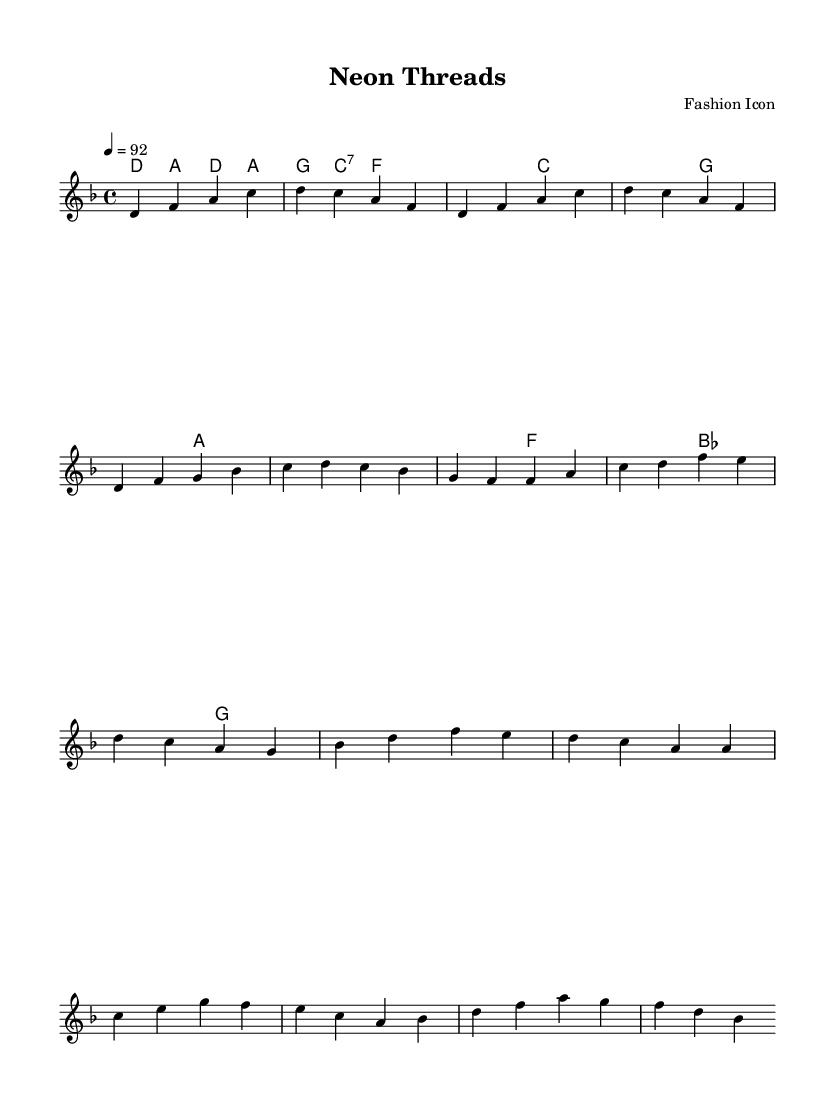What is the key signature of this music? The key signature is D minor, which contains one flat (B flat). This can be determined by looking for the sharps or flats indicated at the beginning of the piece, where the key signature is typically located.
Answer: D minor What is the time signature of this music? The time signature is 4/4, as shown at the beginning of the piece. This means there are four beats in each measure, and a quarter note receives one beat, which is confirmed by the notation after the key signature.
Answer: 4/4 What is the tempo marking of this music? The tempo marking is a quarter note equals 92 beats per minute. This is specified in the tempo directive at the beginning of the score, which indicates how fast the music should be played.
Answer: 92 How many measures are in the chorus section? The chorus section contains four measures, which can be counted by locating the measures in the chart following the introduction and verse sections. Each vertical bar line denotes a measure, and there are four such divisions in the indicated chorus area.
Answer: 4 Which chord is played during the introduction? The first chord in the introduction is D minor. This is established by examining the chord names above the melody in the introduction section, where each chord associated with the corresponding measures is indicated clearly.
Answer: D minor What type of texture is predominantly used in this piece? The predominant texture is a simple homophony, where a primary melody is supported by chordal harmonies. This can be observed by noting the distinct melody line alongside the chord structures that harmonize it throughout the piece.
Answer: Homophony What is the secondary key signature implied in the bridge section? The secondary key signature implied in the bridge section can be considered closer to B flat major due to the presence of B flat and D minor's related chords. Analyzing the harmonies used in this section confirms the relationship and modal interchange.
Answer: B flat major 